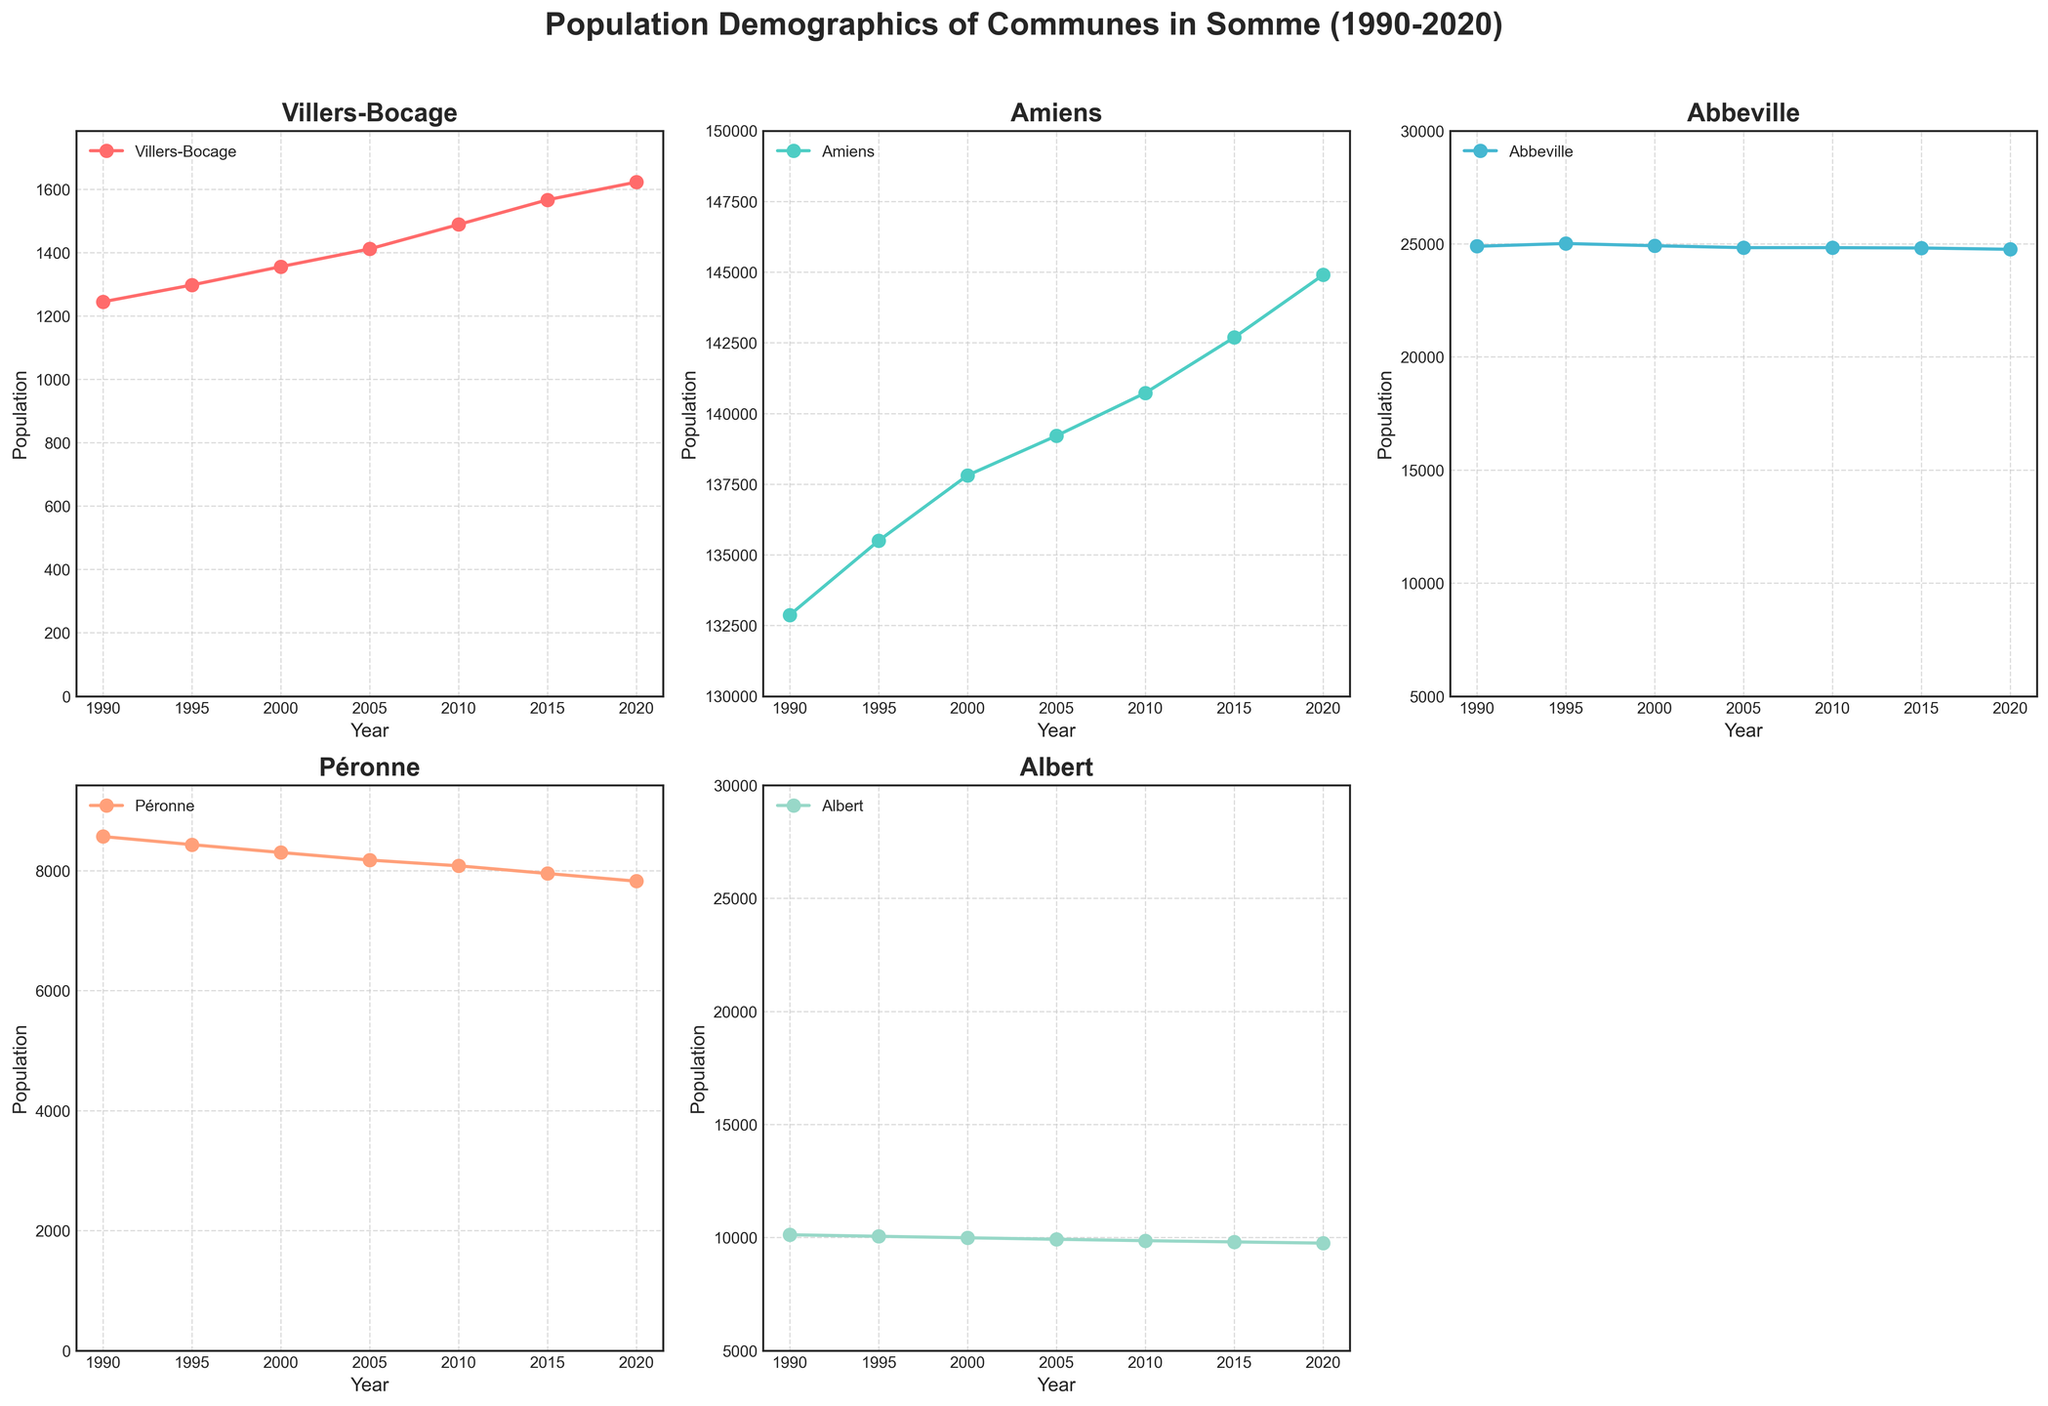How many unique communes are shown in the subplots? The title indicates the population demographics of multiple communes. By observing the labels and titles of each subplot, we can count the unique commune names.
Answer: 5 Which commune experienced the largest population increase from 1990 to 2020? To determine this, we need to compare the population difference between 1990 and 2020 for each commune by subtracting the population in 1990 from the population in 2020. Villers-Bocage: 1623 - 1245, Amiens: 144902 - 132874, Abbeville: 24756 - 24889, Péronne: 7823 - 8567, Albert: 9751 - 10121.
Answer: Amiens What is the title of the figure and what does it imply? The title is "Population Demographics of Communes in Somme (1990-2020)". It implies the figure shows population data for different communes in the Somme department of France over a 30-year period from 1990 to 2020.
Answer: Population Demographics of Communes in Somme (1990-2020) Between which years did Villers-Bocage see the most rapid population growth? By observing the blue line representing Villers-Bocage, look for the segment with the steepest slope. This segment corresponds to the most rapid population growth. Between 2005 and 2010, the population increased from 1412 to 1489, which is the steepest segment.
Answer: 2005 to 2010 How does the population trend of Abbeville compare to that of Albert over the period? By examining the subplots for Abbeville and Albert, we can see that the population of both communes remained relatively stable with slight declines. To compare trends, observe both trends show minor fluctuations around a steady population level.
Answer: Both remained stable with slight declines Which commune had the smallest population in 2020? By looking at the last data point for each commune on the x-axis corresponding to the year 2020, the one with the lowest value on the y-axis represents the smallest population. According to the plot, Péronne had the smallest population.
Answer: Péronne What is the average population of Albert from 1990 to 2020? To calculate the average, add up the population values for Albert from each year: 10121 + 10053 + 9987 + 9921 + 9859 + 9805 + 9751. Then, divide by the number of values (7). (10121 + 10053 + 9987 + 9921 + 9859 + 9805 + 9751) / 7 = 9965.
Answer: 9965 What color represents the population data for Amiens? By observing the plot, each line is a different color. The line for Amiens is the second subplot and has a distinct color. The light green color represents Amiens.
Answer: Light green By what percentage did the population of Amiens increase from 1990 to 2020? To find the percentage increase, subtract the initial value (1990) from the final value (2020), divide the result by the initial value, and multiply by 100. ((144902 - 132874) / 132874) * 100 ≈ 9.1%.
Answer: 9.1% Which commune shows no significant population change over the years? By comparing the slopes of each line, look for a commune where the line remains almost flat, indicating no significant change. Abbeville's population line is nearly horizontal, indicating stability over the years.
Answer: Abbeville 